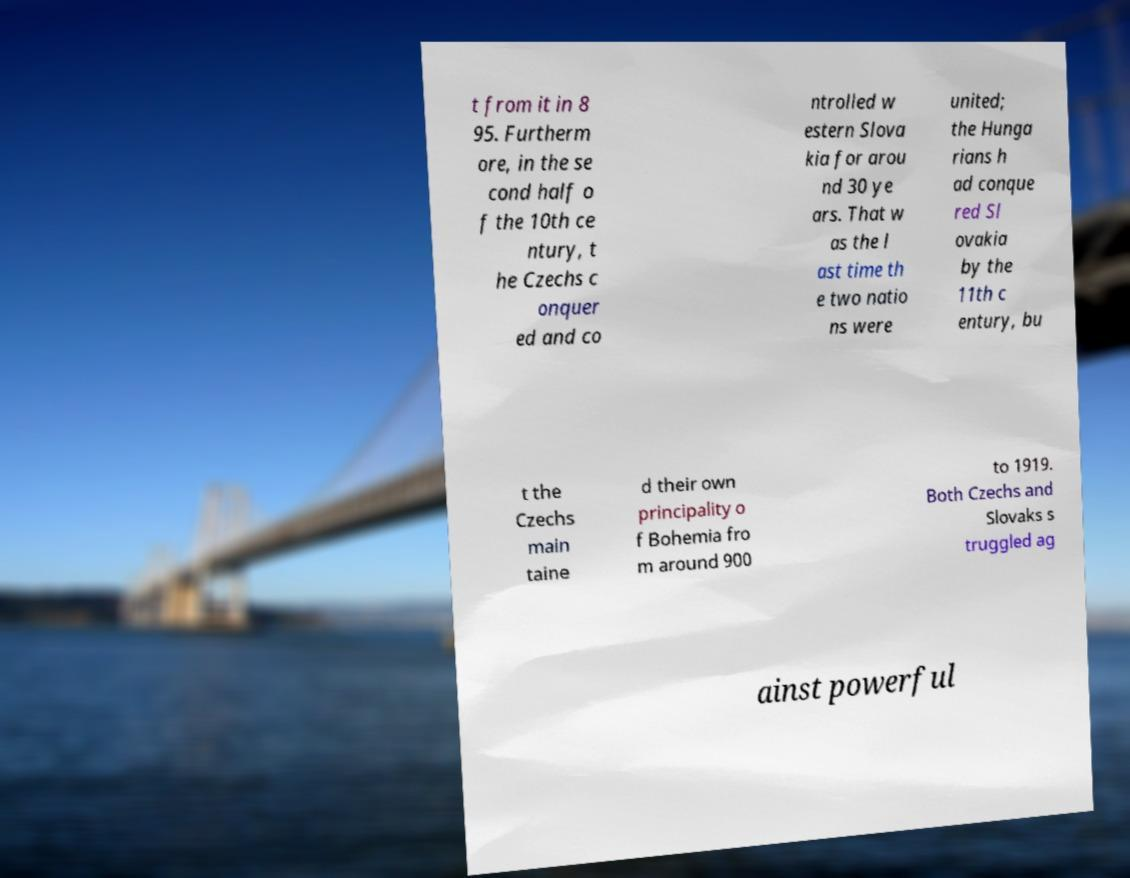Could you assist in decoding the text presented in this image and type it out clearly? t from it in 8 95. Furtherm ore, in the se cond half o f the 10th ce ntury, t he Czechs c onquer ed and co ntrolled w estern Slova kia for arou nd 30 ye ars. That w as the l ast time th e two natio ns were united; the Hunga rians h ad conque red Sl ovakia by the 11th c entury, bu t the Czechs main taine d their own principality o f Bohemia fro m around 900 to 1919. Both Czechs and Slovaks s truggled ag ainst powerful 